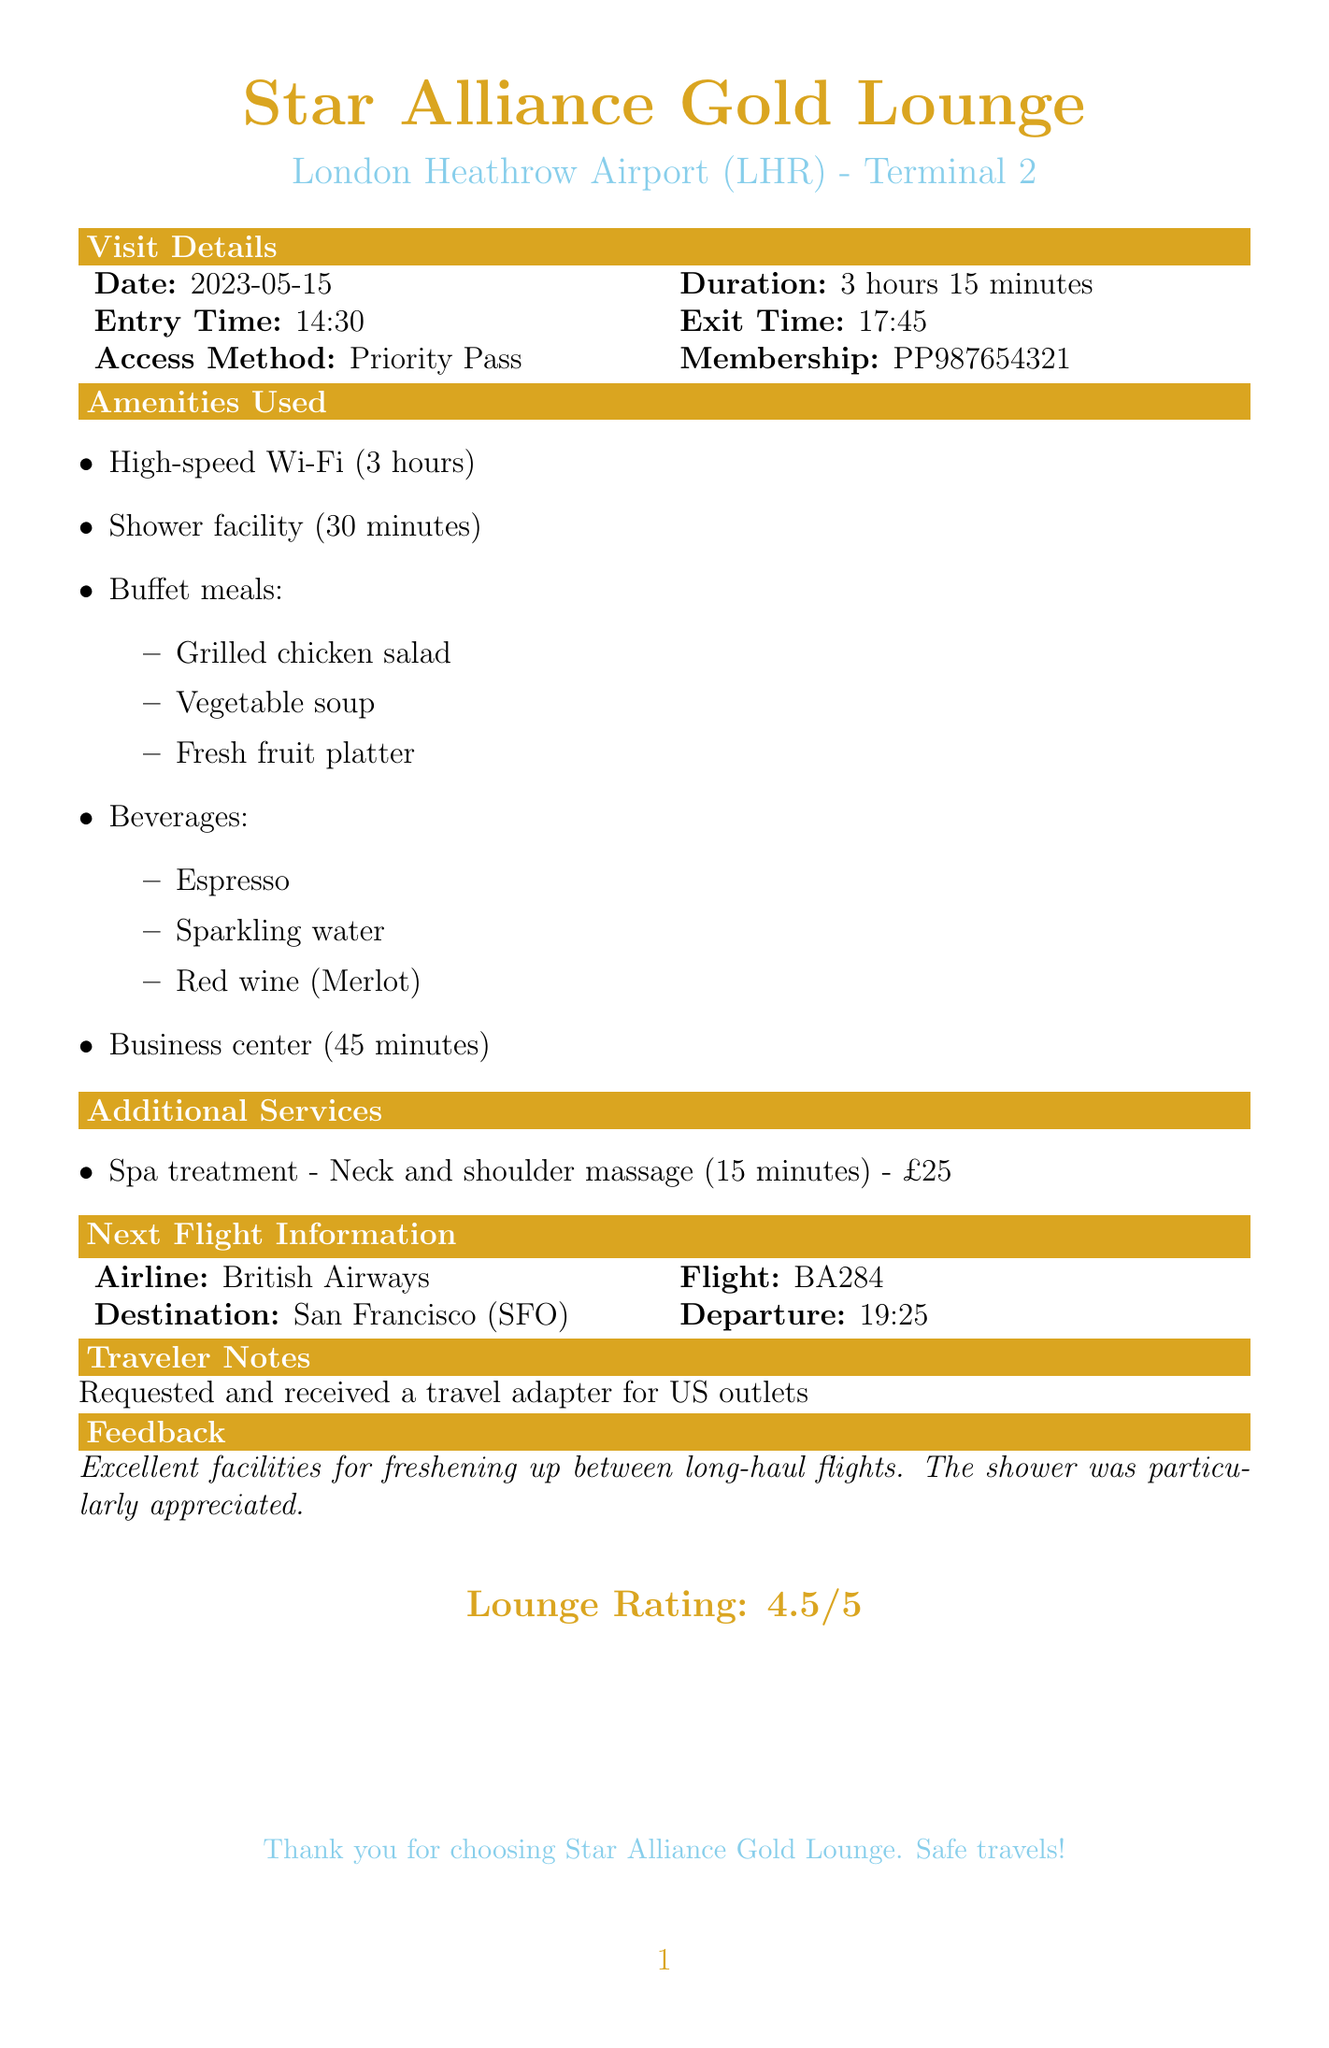What is the name of the lounge? The name of the lounge is provided in the document as the Star Alliance Gold Lounge.
Answer: Star Alliance Gold Lounge What was the duration of the stay? The duration of the stay is mentioned in the visit details section, which is 3 hours 15 minutes.
Answer: 3 hours 15 minutes What amenities were used? The amenities used include High-speed Wi-Fi, Shower facility, Buffet meals, Beverages, and Business center.
Answer: High-speed Wi-Fi, Shower facility, Buffet meals, Beverages, Business center How long was the shower facility used? The duration of the shower facility is listed as 30 minutes in the amenities section.
Answer: 30 minutes What is the membership number? The membership number is directly stated in the document under the access method section.
Answer: PP987654321 What was the cost of the spa treatment? The cost of the spa treatment is explicitly mentioned in the additional services section as £25.
Answer: £25 What time was the exit from the lounge? The exit time is provided in the visit details and is 17:45.
Answer: 17:45 Which airline is the next flight with? The airline for the next flight is found in the next flight information section.
Answer: British Airways What feedback was provided about the lounge? Feedback is provided in the last section of the document, summarizing the experience.
Answer: Excellent facilities for freshening up between long-haul flights 